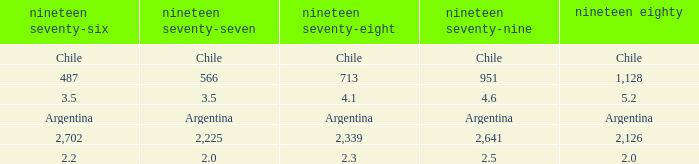What is 1980 when 1978 is 2.3? 2.0. 